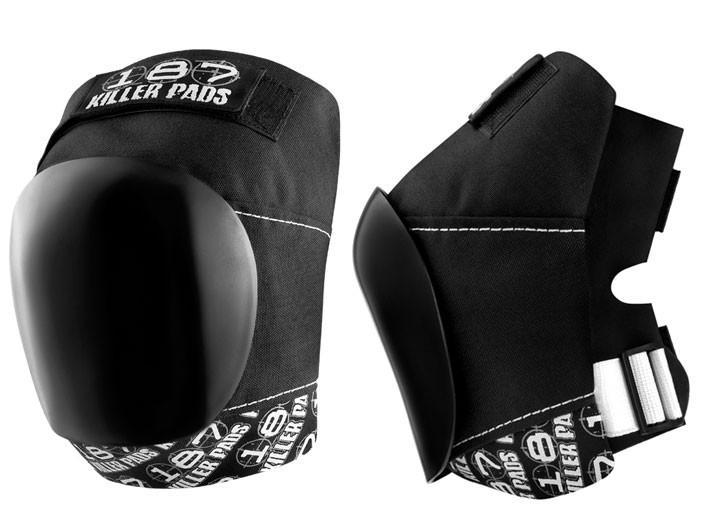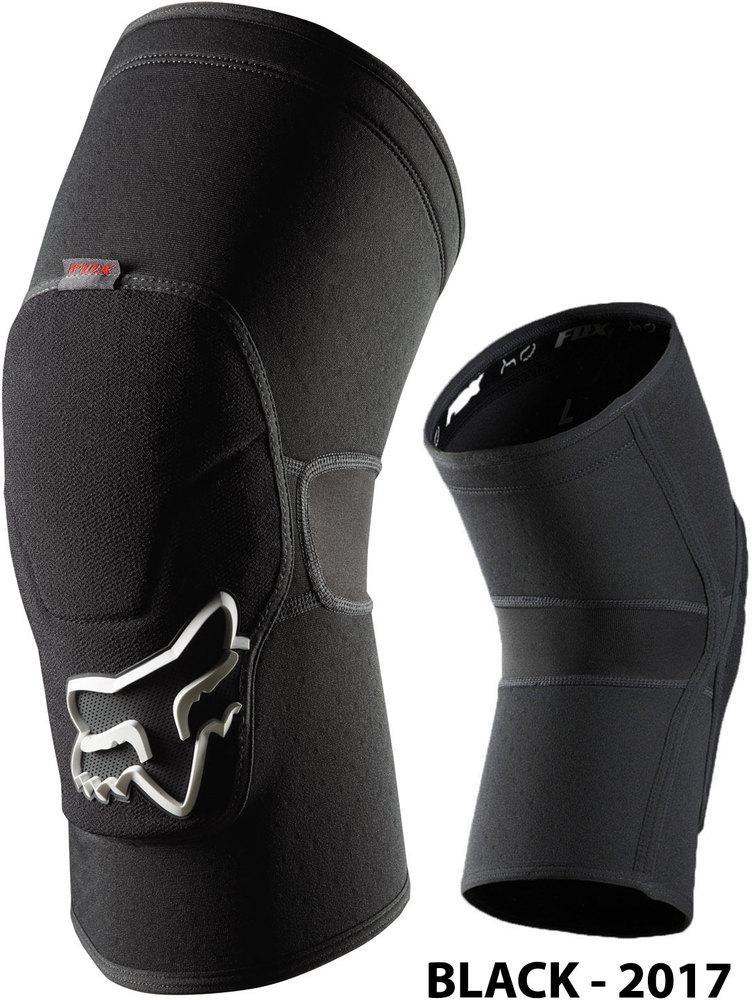The first image is the image on the left, the second image is the image on the right. Evaluate the accuracy of this statement regarding the images: "The two black knee pads face opposite directions.". Is it true? Answer yes or no. Yes. 